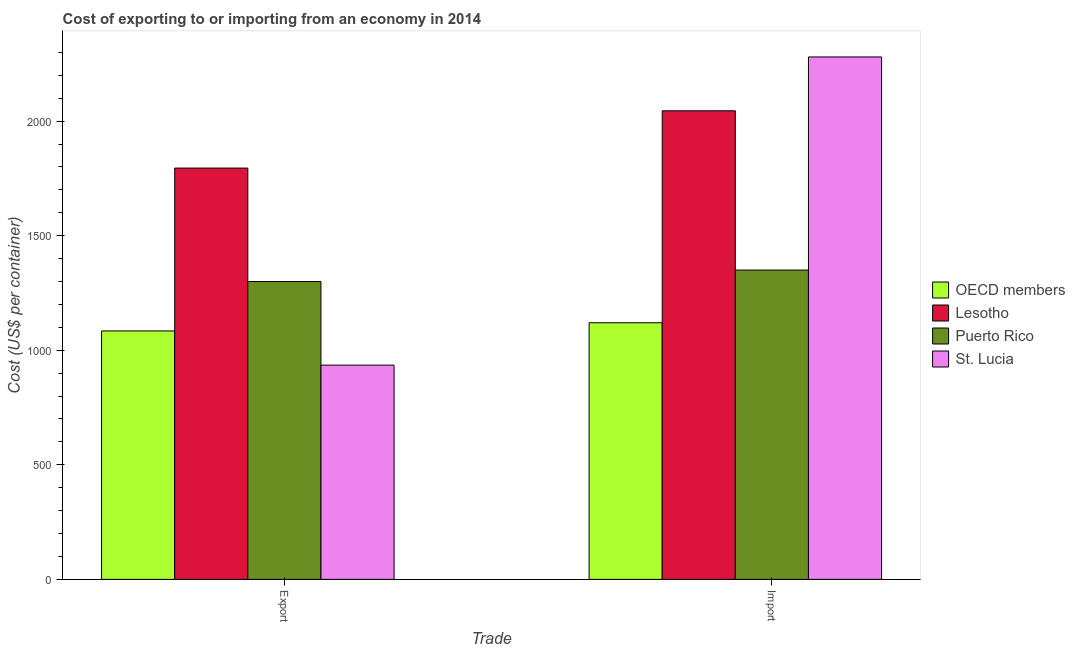How many different coloured bars are there?
Give a very brief answer. 4. How many groups of bars are there?
Provide a short and direct response. 2. Are the number of bars per tick equal to the number of legend labels?
Ensure brevity in your answer.  Yes. Are the number of bars on each tick of the X-axis equal?
Provide a succinct answer. Yes. How many bars are there on the 2nd tick from the right?
Your answer should be very brief. 4. What is the label of the 1st group of bars from the left?
Your response must be concise. Export. What is the export cost in St. Lucia?
Your response must be concise. 935. Across all countries, what is the maximum import cost?
Keep it short and to the point. 2280. Across all countries, what is the minimum export cost?
Your response must be concise. 935. In which country was the export cost maximum?
Ensure brevity in your answer.  Lesotho. What is the total import cost in the graph?
Your response must be concise. 6794.97. What is the difference between the import cost in Puerto Rico and that in Lesotho?
Ensure brevity in your answer.  -695. What is the difference between the export cost in St. Lucia and the import cost in Puerto Rico?
Keep it short and to the point. -415. What is the average import cost per country?
Provide a short and direct response. 1698.74. In how many countries, is the import cost greater than 1000 US$?
Make the answer very short. 4. What is the ratio of the import cost in OECD members to that in Puerto Rico?
Your response must be concise. 0.83. In how many countries, is the import cost greater than the average import cost taken over all countries?
Keep it short and to the point. 2. What does the 3rd bar from the left in Export represents?
Ensure brevity in your answer.  Puerto Rico. What does the 4th bar from the right in Export represents?
Provide a succinct answer. OECD members. How many countries are there in the graph?
Provide a succinct answer. 4. Are the values on the major ticks of Y-axis written in scientific E-notation?
Give a very brief answer. No. Does the graph contain any zero values?
Your answer should be very brief. No. Does the graph contain grids?
Your answer should be compact. No. How are the legend labels stacked?
Give a very brief answer. Vertical. What is the title of the graph?
Keep it short and to the point. Cost of exporting to or importing from an economy in 2014. Does "Egypt, Arab Rep." appear as one of the legend labels in the graph?
Ensure brevity in your answer.  No. What is the label or title of the X-axis?
Offer a terse response. Trade. What is the label or title of the Y-axis?
Your response must be concise. Cost (US$ per container). What is the Cost (US$ per container) in OECD members in Export?
Offer a terse response. 1084.19. What is the Cost (US$ per container) of Lesotho in Export?
Your answer should be very brief. 1795. What is the Cost (US$ per container) of Puerto Rico in Export?
Provide a short and direct response. 1300. What is the Cost (US$ per container) of St. Lucia in Export?
Offer a very short reply. 935. What is the Cost (US$ per container) in OECD members in Import?
Your response must be concise. 1119.97. What is the Cost (US$ per container) in Lesotho in Import?
Your response must be concise. 2045. What is the Cost (US$ per container) of Puerto Rico in Import?
Provide a succinct answer. 1350. What is the Cost (US$ per container) in St. Lucia in Import?
Your response must be concise. 2280. Across all Trade, what is the maximum Cost (US$ per container) of OECD members?
Provide a succinct answer. 1119.97. Across all Trade, what is the maximum Cost (US$ per container) of Lesotho?
Your answer should be compact. 2045. Across all Trade, what is the maximum Cost (US$ per container) in Puerto Rico?
Your answer should be very brief. 1350. Across all Trade, what is the maximum Cost (US$ per container) in St. Lucia?
Ensure brevity in your answer.  2280. Across all Trade, what is the minimum Cost (US$ per container) of OECD members?
Offer a very short reply. 1084.19. Across all Trade, what is the minimum Cost (US$ per container) in Lesotho?
Your answer should be compact. 1795. Across all Trade, what is the minimum Cost (US$ per container) of Puerto Rico?
Your response must be concise. 1300. Across all Trade, what is the minimum Cost (US$ per container) of St. Lucia?
Offer a terse response. 935. What is the total Cost (US$ per container) of OECD members in the graph?
Offer a terse response. 2204.16. What is the total Cost (US$ per container) in Lesotho in the graph?
Offer a terse response. 3840. What is the total Cost (US$ per container) in Puerto Rico in the graph?
Give a very brief answer. 2650. What is the total Cost (US$ per container) of St. Lucia in the graph?
Keep it short and to the point. 3215. What is the difference between the Cost (US$ per container) of OECD members in Export and that in Import?
Give a very brief answer. -35.77. What is the difference between the Cost (US$ per container) of Lesotho in Export and that in Import?
Your answer should be very brief. -250. What is the difference between the Cost (US$ per container) of St. Lucia in Export and that in Import?
Offer a very short reply. -1345. What is the difference between the Cost (US$ per container) in OECD members in Export and the Cost (US$ per container) in Lesotho in Import?
Ensure brevity in your answer.  -960.81. What is the difference between the Cost (US$ per container) in OECD members in Export and the Cost (US$ per container) in Puerto Rico in Import?
Your answer should be compact. -265.81. What is the difference between the Cost (US$ per container) in OECD members in Export and the Cost (US$ per container) in St. Lucia in Import?
Your response must be concise. -1195.81. What is the difference between the Cost (US$ per container) of Lesotho in Export and the Cost (US$ per container) of Puerto Rico in Import?
Make the answer very short. 445. What is the difference between the Cost (US$ per container) in Lesotho in Export and the Cost (US$ per container) in St. Lucia in Import?
Your answer should be compact. -485. What is the difference between the Cost (US$ per container) in Puerto Rico in Export and the Cost (US$ per container) in St. Lucia in Import?
Give a very brief answer. -980. What is the average Cost (US$ per container) of OECD members per Trade?
Keep it short and to the point. 1102.08. What is the average Cost (US$ per container) of Lesotho per Trade?
Your answer should be very brief. 1920. What is the average Cost (US$ per container) of Puerto Rico per Trade?
Make the answer very short. 1325. What is the average Cost (US$ per container) of St. Lucia per Trade?
Your answer should be compact. 1607.5. What is the difference between the Cost (US$ per container) in OECD members and Cost (US$ per container) in Lesotho in Export?
Make the answer very short. -710.81. What is the difference between the Cost (US$ per container) in OECD members and Cost (US$ per container) in Puerto Rico in Export?
Your answer should be very brief. -215.81. What is the difference between the Cost (US$ per container) in OECD members and Cost (US$ per container) in St. Lucia in Export?
Keep it short and to the point. 149.19. What is the difference between the Cost (US$ per container) of Lesotho and Cost (US$ per container) of Puerto Rico in Export?
Give a very brief answer. 495. What is the difference between the Cost (US$ per container) in Lesotho and Cost (US$ per container) in St. Lucia in Export?
Offer a very short reply. 860. What is the difference between the Cost (US$ per container) of Puerto Rico and Cost (US$ per container) of St. Lucia in Export?
Ensure brevity in your answer.  365. What is the difference between the Cost (US$ per container) of OECD members and Cost (US$ per container) of Lesotho in Import?
Your response must be concise. -925.03. What is the difference between the Cost (US$ per container) of OECD members and Cost (US$ per container) of Puerto Rico in Import?
Offer a terse response. -230.03. What is the difference between the Cost (US$ per container) of OECD members and Cost (US$ per container) of St. Lucia in Import?
Provide a short and direct response. -1160.03. What is the difference between the Cost (US$ per container) in Lesotho and Cost (US$ per container) in Puerto Rico in Import?
Your response must be concise. 695. What is the difference between the Cost (US$ per container) in Lesotho and Cost (US$ per container) in St. Lucia in Import?
Ensure brevity in your answer.  -235. What is the difference between the Cost (US$ per container) in Puerto Rico and Cost (US$ per container) in St. Lucia in Import?
Provide a succinct answer. -930. What is the ratio of the Cost (US$ per container) in OECD members in Export to that in Import?
Give a very brief answer. 0.97. What is the ratio of the Cost (US$ per container) of Lesotho in Export to that in Import?
Give a very brief answer. 0.88. What is the ratio of the Cost (US$ per container) of St. Lucia in Export to that in Import?
Make the answer very short. 0.41. What is the difference between the highest and the second highest Cost (US$ per container) of OECD members?
Give a very brief answer. 35.77. What is the difference between the highest and the second highest Cost (US$ per container) in Lesotho?
Provide a succinct answer. 250. What is the difference between the highest and the second highest Cost (US$ per container) of St. Lucia?
Keep it short and to the point. 1345. What is the difference between the highest and the lowest Cost (US$ per container) in OECD members?
Provide a short and direct response. 35.77. What is the difference between the highest and the lowest Cost (US$ per container) of Lesotho?
Your answer should be compact. 250. What is the difference between the highest and the lowest Cost (US$ per container) in Puerto Rico?
Your answer should be compact. 50. What is the difference between the highest and the lowest Cost (US$ per container) in St. Lucia?
Your answer should be compact. 1345. 